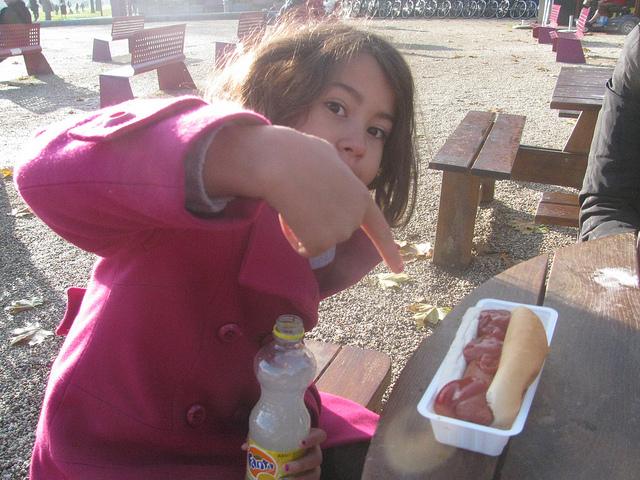What is the little girl drinking?
Quick response, please. Fanta. What type of food is on the table?
Short answer required. Hot dog. What is the girl eating?
Concise answer only. Hot dog. Is this little girl wearing a white hat with a flower?
Answer briefly. No. Is there ketchup on the food?
Short answer required. Yes. 